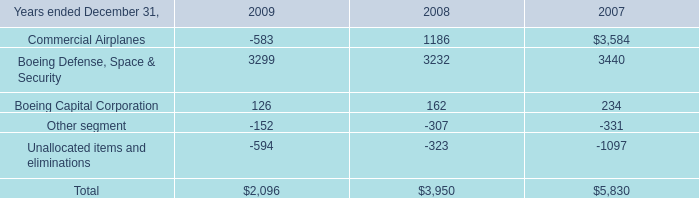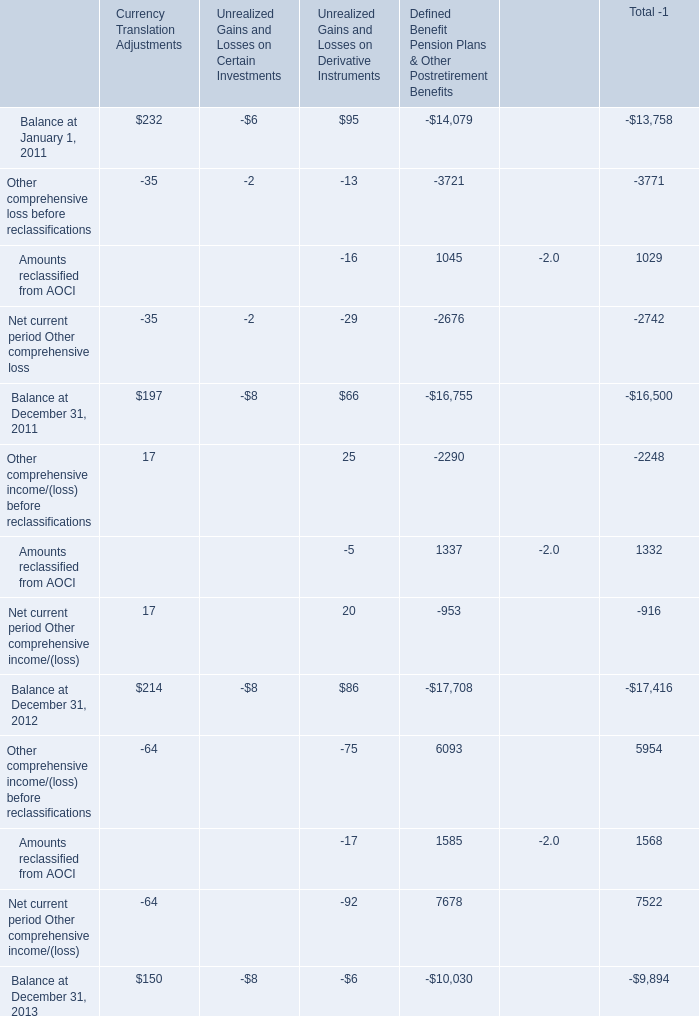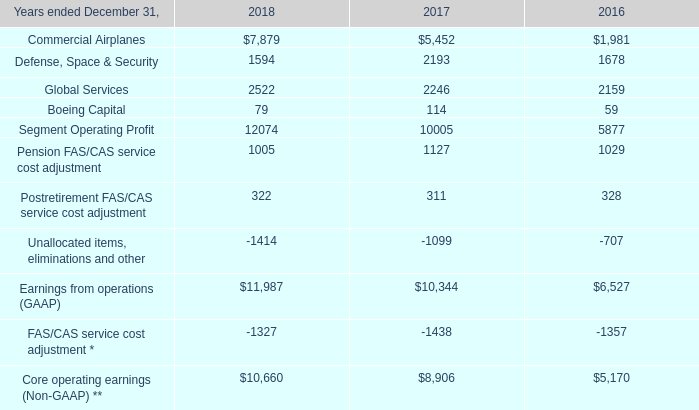What is the total amount of Commercial Airplanes of 2007, and FAS/CAS service cost adjustment * of 2017 ? 
Computations: (3584.0 + 1438.0)
Answer: 5022.0. 